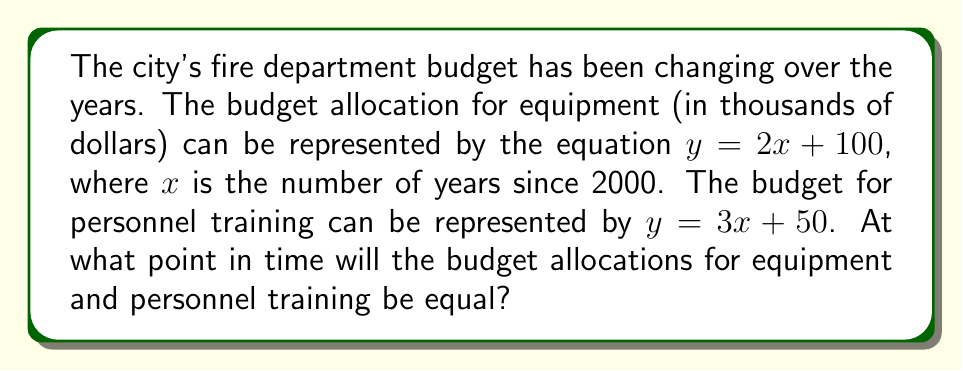Give your solution to this math problem. To find the point where the two budget allocations are equal, we need to find the intersection point of the two linear equations. Let's solve this step-by-step:

1) We have two equations:
   Equipment budget: $y = 2x + 100$
   Training budget: $y = 3x + 50$

2) At the intersection point, both $y$ values will be equal. So we can set the equations equal to each other:
   $2x + 100 = 3x + 50$

3) Now, let's solve for $x$:
   $2x + 100 = 3x + 50$
   $100 - 50 = 3x - 2x$
   $50 = x$

4) So, the equations intersect when $x = 50$. This means 50 years after 2000, which is the year 2050.

5) To find the $y$ value (the budget amount), we can plug $x = 50$ into either equation. Let's use the equipment budget equation:
   $y = 2(50) + 100 = 100 + 100 = 200$

6) Therefore, the intersection point is $(50, 200)$, meaning in the year 2050, both equipment and training budgets will be $200,000.
Answer: $(50, 200)$, representing the year 2050 and $200,000 budget 